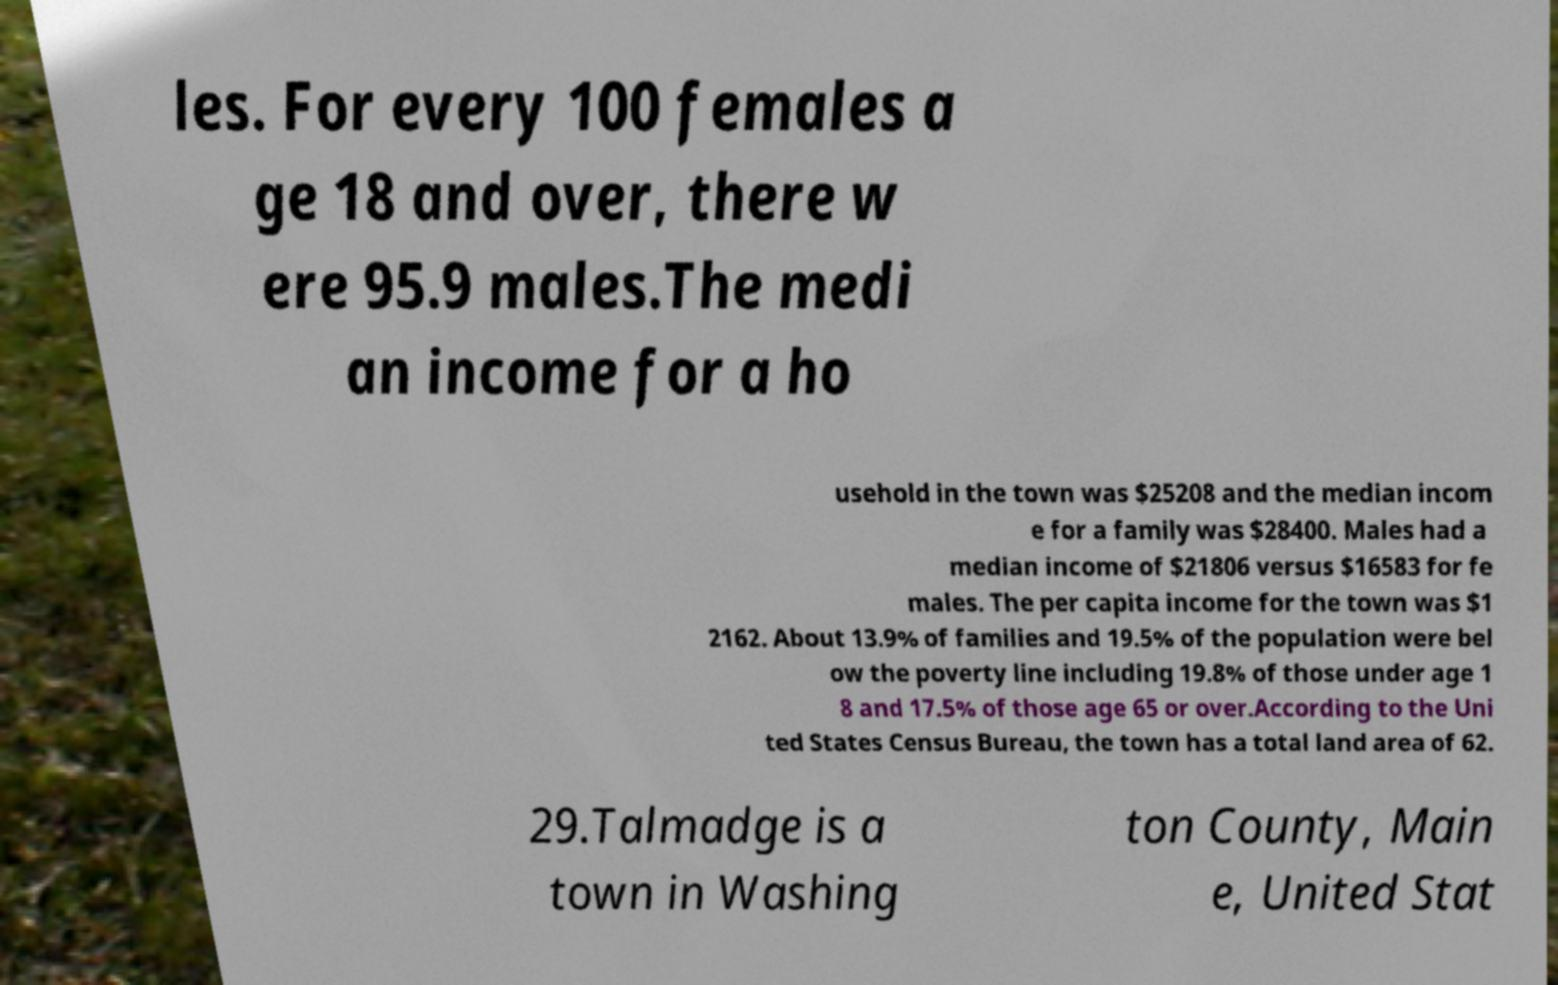Could you extract and type out the text from this image? les. For every 100 females a ge 18 and over, there w ere 95.9 males.The medi an income for a ho usehold in the town was $25208 and the median incom e for a family was $28400. Males had a median income of $21806 versus $16583 for fe males. The per capita income for the town was $1 2162. About 13.9% of families and 19.5% of the population were bel ow the poverty line including 19.8% of those under age 1 8 and 17.5% of those age 65 or over.According to the Uni ted States Census Bureau, the town has a total land area of 62. 29.Talmadge is a town in Washing ton County, Main e, United Stat 